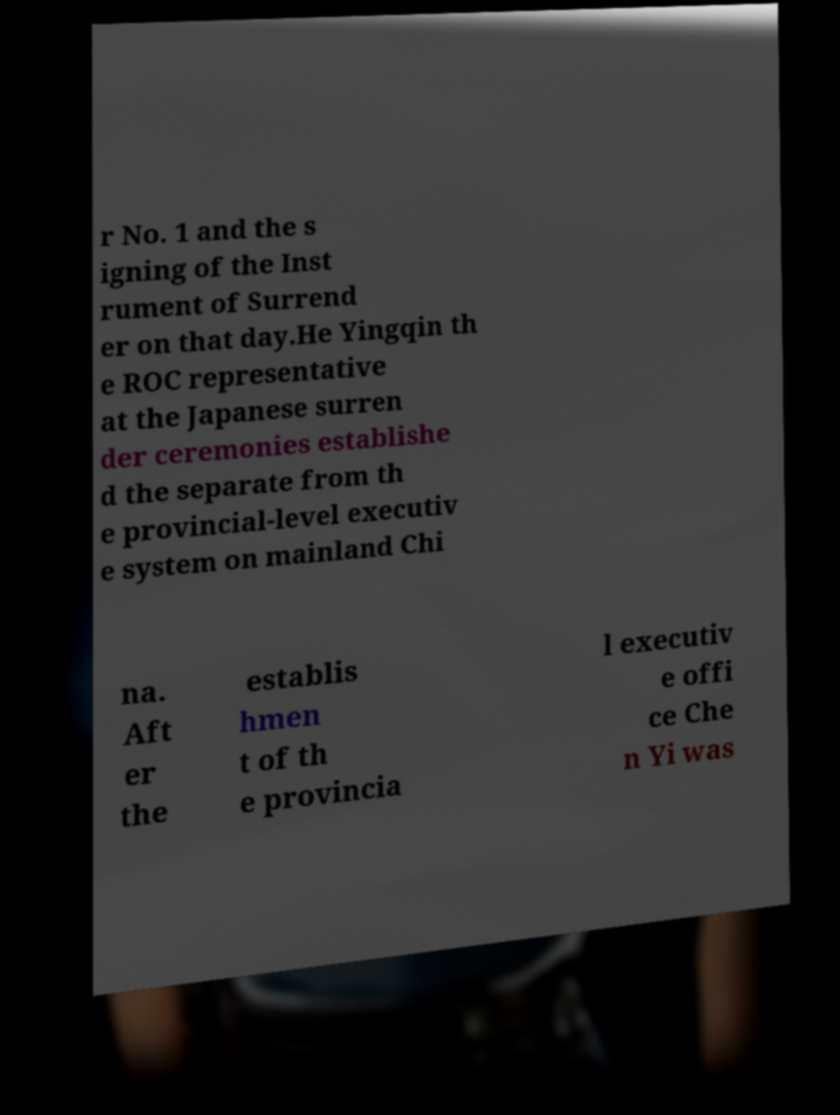Can you accurately transcribe the text from the provided image for me? r No. 1 and the s igning of the Inst rument of Surrend er on that day.He Yingqin th e ROC representative at the Japanese surren der ceremonies establishe d the separate from th e provincial-level executiv e system on mainland Chi na. Aft er the establis hmen t of th e provincia l executiv e offi ce Che n Yi was 